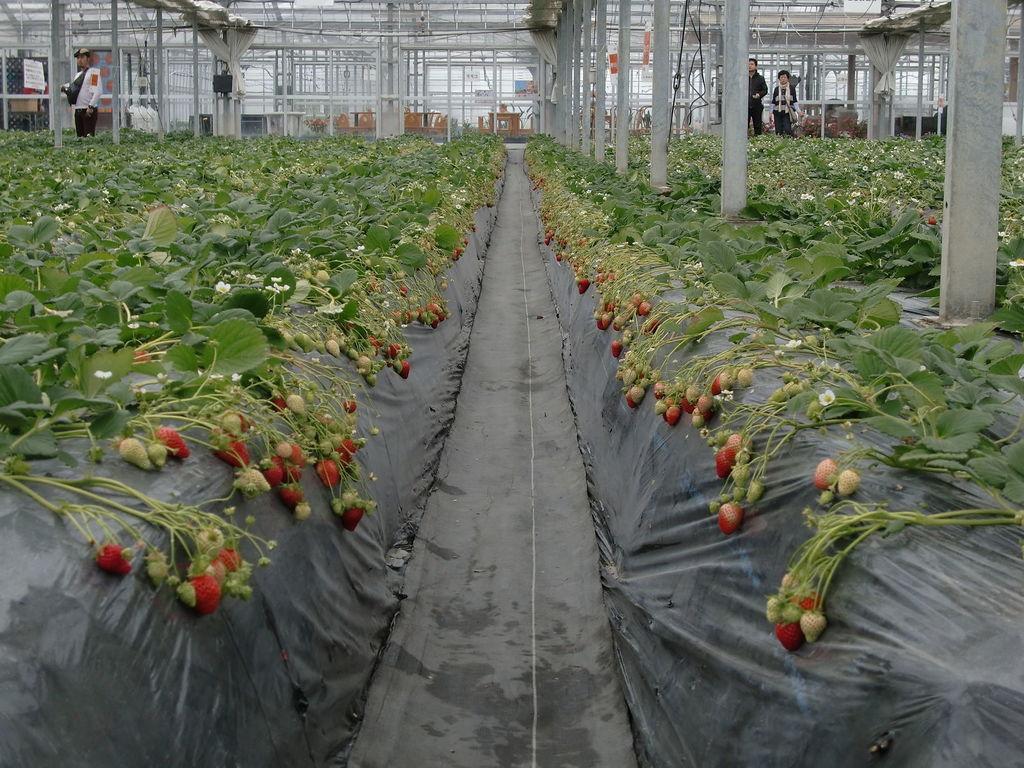Describe this image in one or two sentences. In this picture i can see the nursery plant. At the bottom i can see the black plastic cover, beside that we can see fruits. In the top left there is a man who is standing near to the poles and he is holding a paper. In the top right there are two persons were standing near to the plants. In the background we can see the table and chairs. 